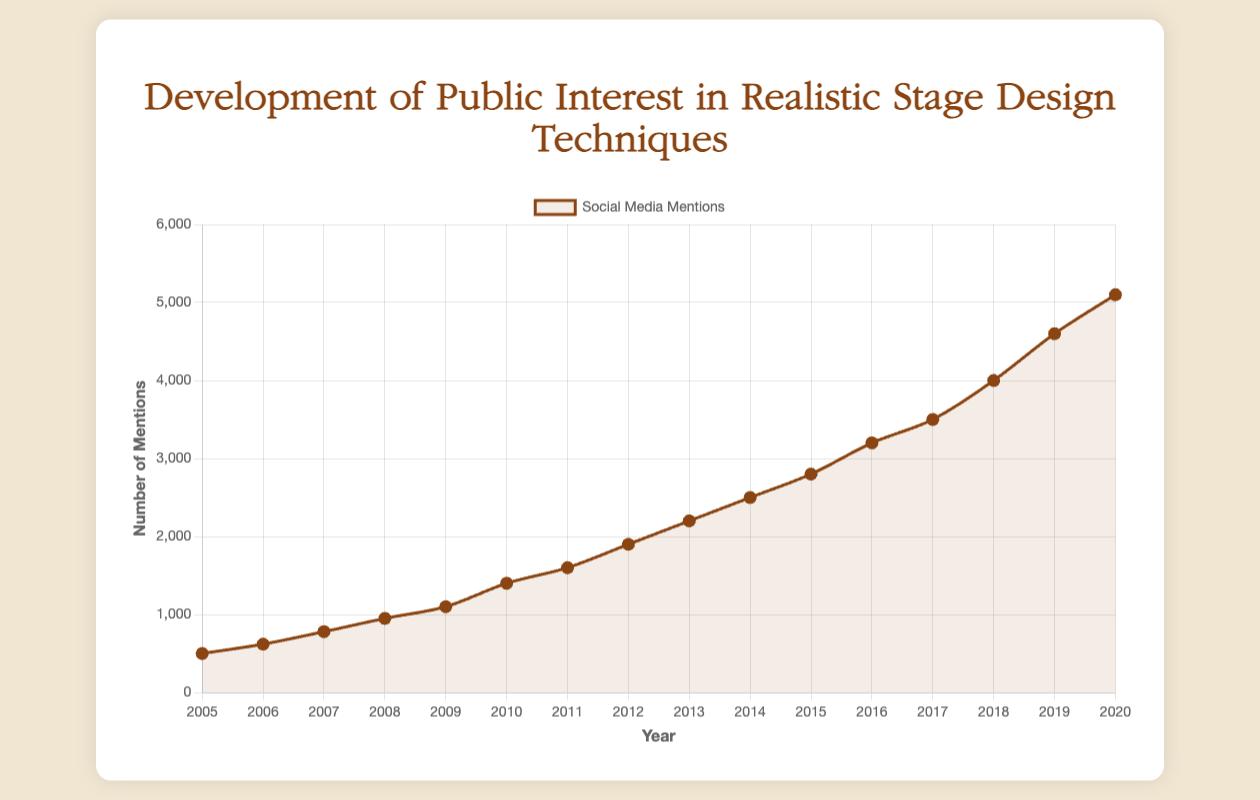What is the total number of social media mentions in 2012? From the figure, locate 2012 on the x-axis and identify the corresponding data point on the line for social media mentions. The y-value at this point indicates the number of mentions.
Answer: 1900 Which year had the highest social media mentions and how many? Look for the data point on the line chart that reaches the highest point on the y-axis. The year associated with this point on the x-axis is the answer, along with the corresponding y-value.
Answer: 2020, 5100 How many social media mentions were there in total from 2005 to 2008? Sum the number of mentions from 2005 to 2008 by extracting the values from the figure. (500 + 620 + 780 + 950).
Answer: 2850 Which year saw the first appearance of Instagram as a major media platform and how many mentions did it have that year? Locate the year when Instagram is first listed and note the number of mentions.
Answer: 2015, 1600 